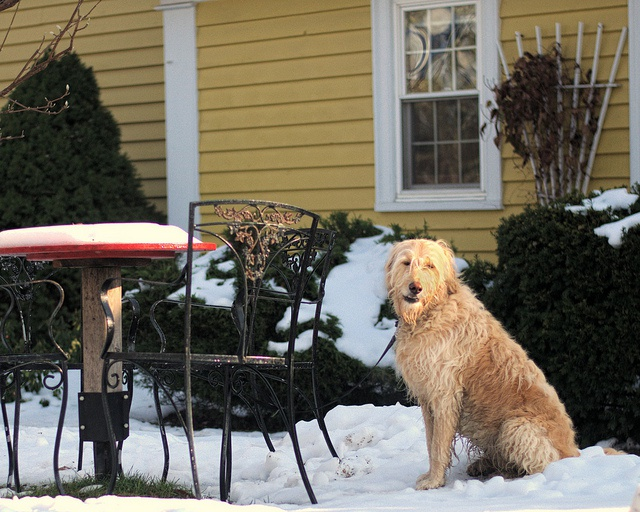Describe the objects in this image and their specific colors. I can see dog in black, tan, and gray tones, chair in black, gray, and olive tones, dining table in black, ivory, gray, and maroon tones, and chair in black, gray, lightgray, and darkgray tones in this image. 